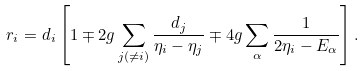Convert formula to latex. <formula><loc_0><loc_0><loc_500><loc_500>r _ { i } = d _ { i } \left [ 1 \mp 2 g \sum _ { j \left ( \neq i \right ) } \frac { d _ { j } } { \eta _ { i } - \eta _ { j } } \mp 4 g \sum _ { \alpha } \frac { 1 } { 2 \eta _ { i } - E _ { \alpha } } \right ] .</formula> 